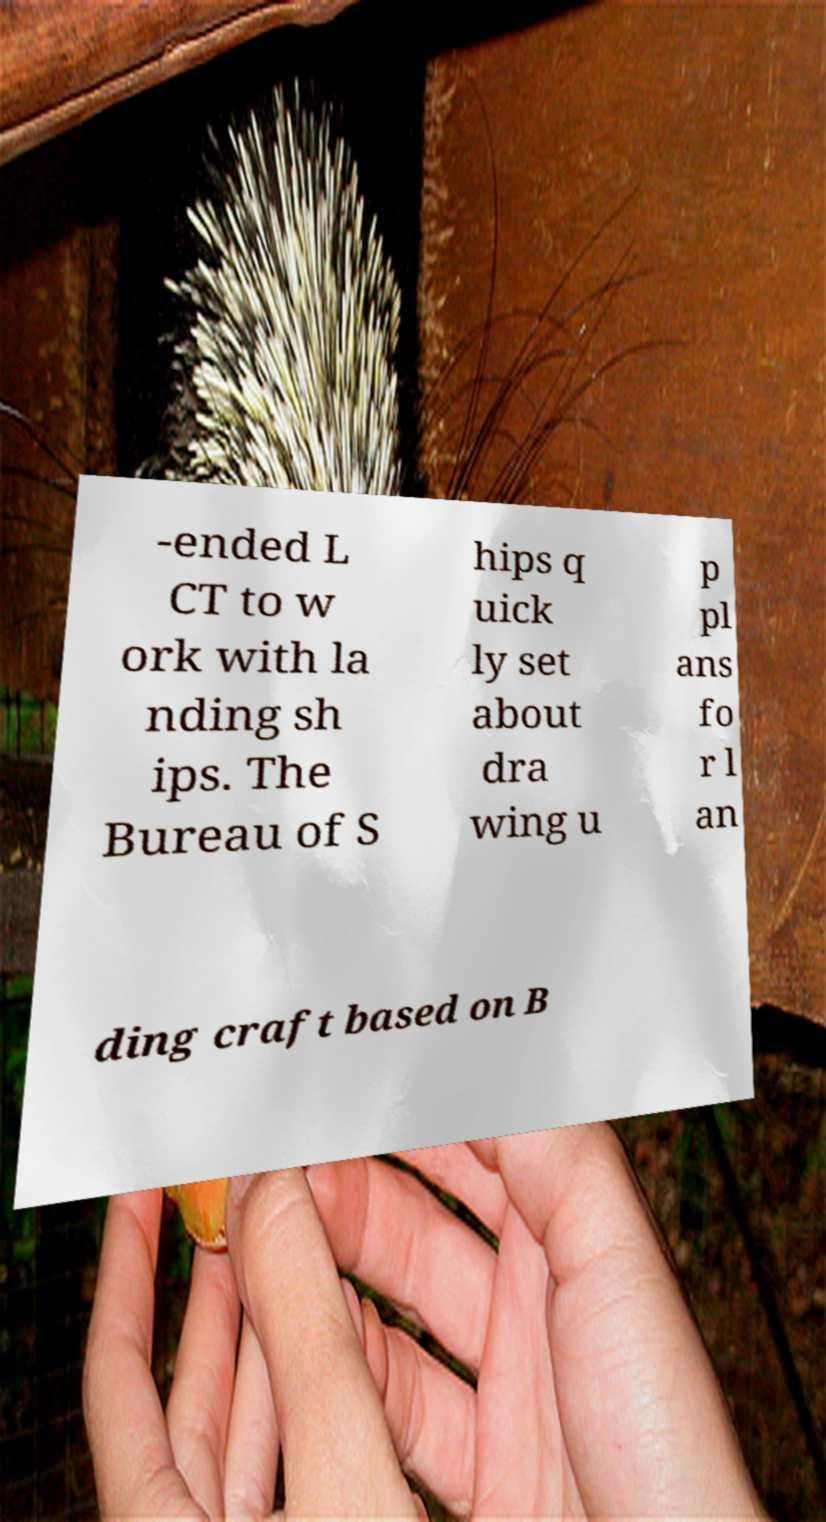Could you extract and type out the text from this image? -ended L CT to w ork with la nding sh ips. The Bureau of S hips q uick ly set about dra wing u p pl ans fo r l an ding craft based on B 